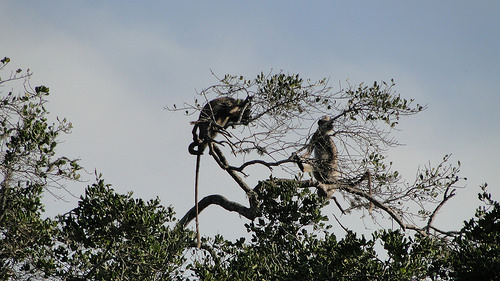<image>
Can you confirm if the sky is behind the monkey? Yes. From this viewpoint, the sky is positioned behind the monkey, with the monkey partially or fully occluding the sky. 